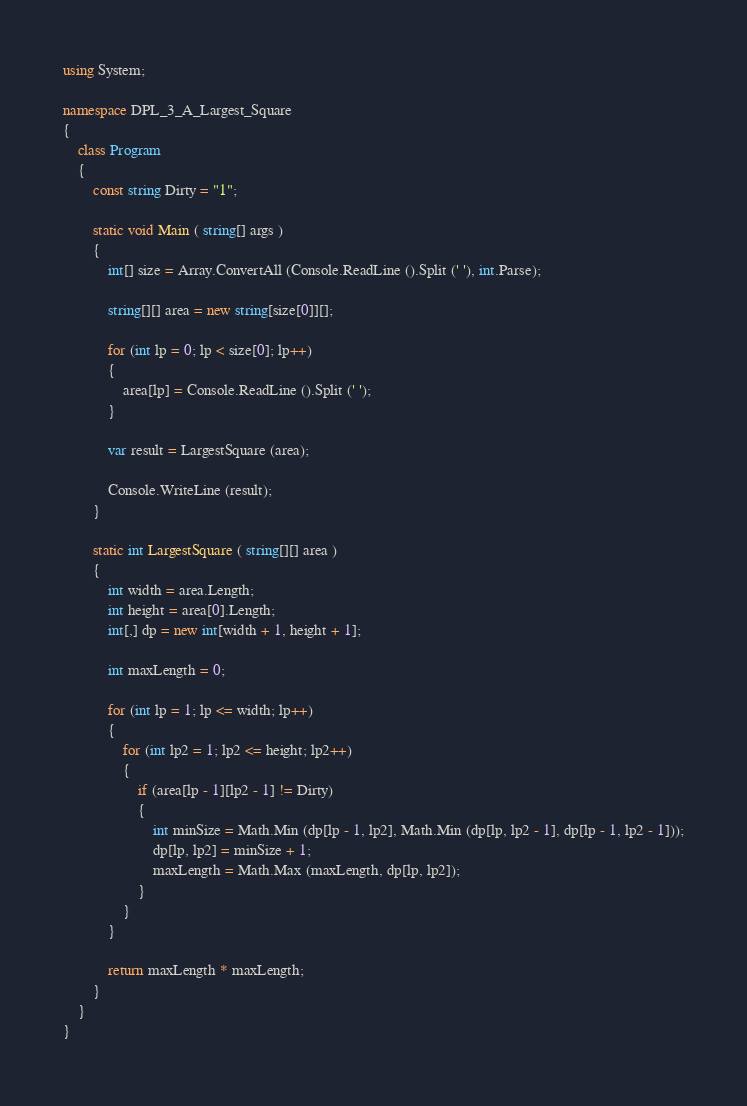<code> <loc_0><loc_0><loc_500><loc_500><_C#_>using System;

namespace DPL_3_A_Largest_Square
{
	class Program
	{
		const string Dirty = "1";

		static void Main ( string[] args )
		{
			int[] size = Array.ConvertAll (Console.ReadLine ().Split (' '), int.Parse);

			string[][] area = new string[size[0]][];

			for (int lp = 0; lp < size[0]; lp++)
			{
				area[lp] = Console.ReadLine ().Split (' ');
			}

			var result = LargestSquare (area);

			Console.WriteLine (result);
		}

		static int LargestSquare ( string[][] area )
		{
			int width = area.Length;
			int height = area[0].Length;
			int[,] dp = new int[width + 1, height + 1];

			int maxLength = 0;

			for (int lp = 1; lp <= width; lp++)
			{
				for (int lp2 = 1; lp2 <= height; lp2++)
				{
					if (area[lp - 1][lp2 - 1] != Dirty)
					{
						int minSize = Math.Min (dp[lp - 1, lp2], Math.Min (dp[lp, lp2 - 1], dp[lp - 1, lp2 - 1]));
						dp[lp, lp2] = minSize + 1;
						maxLength = Math.Max (maxLength, dp[lp, lp2]);
					}
				}
			}

			return maxLength * maxLength;
		}
	}
}

</code> 